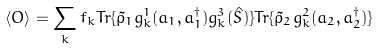Convert formula to latex. <formula><loc_0><loc_0><loc_500><loc_500>\langle O \rangle = \sum _ { k } { f _ { k } T r \{ \tilde { \rho } _ { 1 } g ^ { 1 } _ { k } ( a _ { 1 } , a _ { 1 } ^ { \dag } ) g _ { k } ^ { 3 } ( \hat { S } ) \} T r \{ \tilde { \rho } _ { 2 } g _ { k } ^ { 2 } ( a _ { 2 } , a _ { 2 } ^ { \dag } ) \} }</formula> 